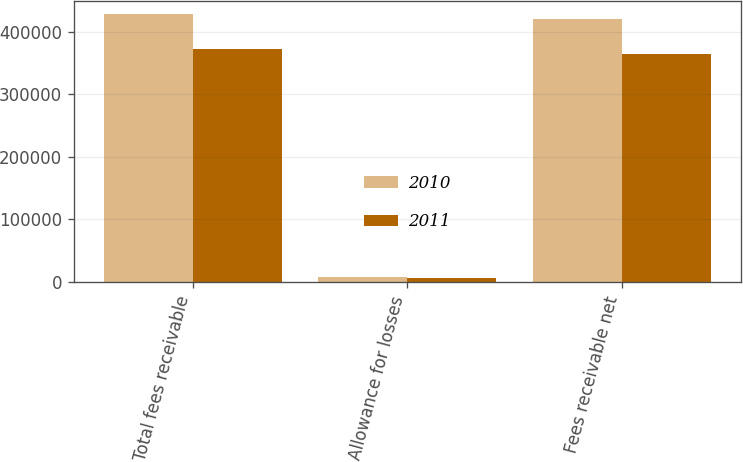Convert chart. <chart><loc_0><loc_0><loc_500><loc_500><stacked_bar_chart><ecel><fcel>Total fees receivable<fcel>Allowance for losses<fcel>Fees receivable net<nl><fcel>2010<fcel>428293<fcel>7260<fcel>421033<nl><fcel>2011<fcel>372018<fcel>7200<fcel>364818<nl></chart> 